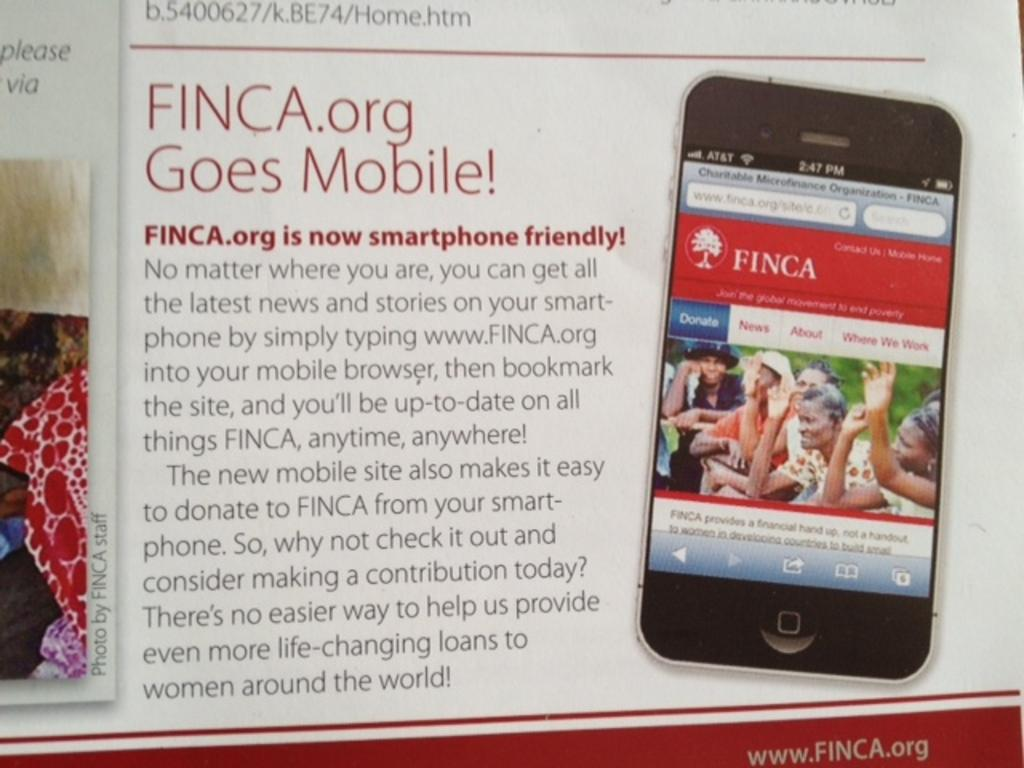<image>
Offer a succinct explanation of the picture presented. A poster shows that the FINCA.org website is now smartphone friendly. 